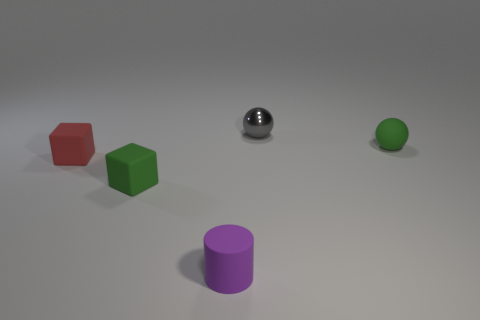Add 2 large gray things. How many objects exist? 7 Subtract all cubes. How many objects are left? 3 Add 3 small gray metallic balls. How many small gray metallic balls exist? 4 Subtract 1 green blocks. How many objects are left? 4 Subtract all tiny cubes. Subtract all small brown matte cubes. How many objects are left? 3 Add 2 matte cubes. How many matte cubes are left? 4 